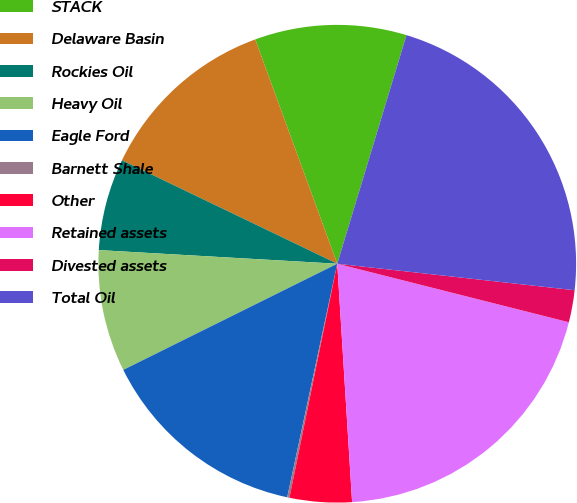Convert chart. <chart><loc_0><loc_0><loc_500><loc_500><pie_chart><fcel>STACK<fcel>Delaware Basin<fcel>Rockies Oil<fcel>Heavy Oil<fcel>Eagle Ford<fcel>Barnett Shale<fcel>Other<fcel>Retained assets<fcel>Divested assets<fcel>Total Oil<nl><fcel>10.26%<fcel>12.29%<fcel>6.22%<fcel>8.24%<fcel>14.31%<fcel>0.15%<fcel>4.2%<fcel>20.07%<fcel>2.17%<fcel>22.09%<nl></chart> 